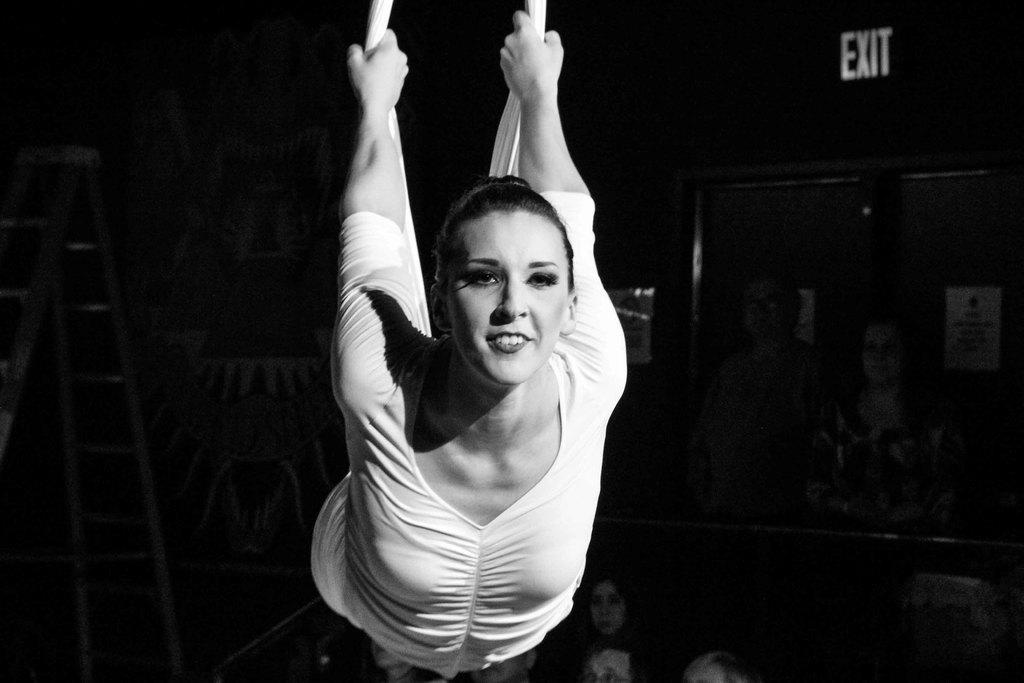Who is the main subject in the image? There is a woman in the image. What is the woman holding? The woman is holding clothes. Can you describe the background of the image? The background of the image is dark. What else can be seen in the background of the image? There are people, a ladder, posters, and a board in the background of the image. What type of toothpaste is the goat using in the image? There is no goat or toothpaste present in the image. 